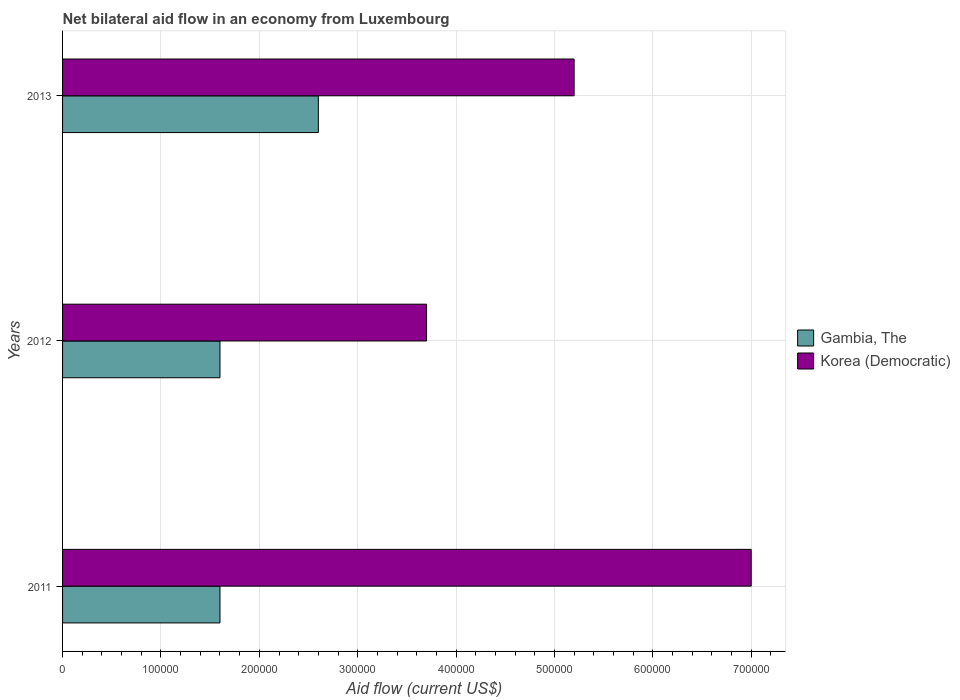How many bars are there on the 1st tick from the bottom?
Offer a terse response. 2. What is the label of the 1st group of bars from the top?
Offer a terse response. 2013. What is the net bilateral aid flow in Gambia, The in 2013?
Offer a very short reply. 2.60e+05. In which year was the net bilateral aid flow in Korea (Democratic) maximum?
Your response must be concise. 2011. In which year was the net bilateral aid flow in Gambia, The minimum?
Offer a very short reply. 2011. What is the total net bilateral aid flow in Gambia, The in the graph?
Your answer should be compact. 5.80e+05. What is the difference between the net bilateral aid flow in Gambia, The in 2011 and the net bilateral aid flow in Korea (Democratic) in 2013?
Offer a terse response. -3.60e+05. What is the average net bilateral aid flow in Gambia, The per year?
Provide a short and direct response. 1.93e+05. In the year 2011, what is the difference between the net bilateral aid flow in Gambia, The and net bilateral aid flow in Korea (Democratic)?
Your answer should be very brief. -5.40e+05. What is the ratio of the net bilateral aid flow in Korea (Democratic) in 2011 to that in 2013?
Ensure brevity in your answer.  1.35. Is the difference between the net bilateral aid flow in Gambia, The in 2011 and 2012 greater than the difference between the net bilateral aid flow in Korea (Democratic) in 2011 and 2012?
Offer a terse response. No. Is the sum of the net bilateral aid flow in Gambia, The in 2012 and 2013 greater than the maximum net bilateral aid flow in Korea (Democratic) across all years?
Make the answer very short. No. What does the 1st bar from the top in 2013 represents?
Provide a short and direct response. Korea (Democratic). What does the 1st bar from the bottom in 2013 represents?
Keep it short and to the point. Gambia, The. Are the values on the major ticks of X-axis written in scientific E-notation?
Make the answer very short. No. Where does the legend appear in the graph?
Provide a succinct answer. Center right. What is the title of the graph?
Give a very brief answer. Net bilateral aid flow in an economy from Luxembourg. What is the label or title of the Y-axis?
Keep it short and to the point. Years. What is the Aid flow (current US$) of Gambia, The in 2012?
Provide a short and direct response. 1.60e+05. What is the Aid flow (current US$) of Gambia, The in 2013?
Give a very brief answer. 2.60e+05. What is the Aid flow (current US$) of Korea (Democratic) in 2013?
Your answer should be very brief. 5.20e+05. Across all years, what is the maximum Aid flow (current US$) of Korea (Democratic)?
Provide a succinct answer. 7.00e+05. Across all years, what is the minimum Aid flow (current US$) in Gambia, The?
Your answer should be compact. 1.60e+05. What is the total Aid flow (current US$) of Gambia, The in the graph?
Keep it short and to the point. 5.80e+05. What is the total Aid flow (current US$) of Korea (Democratic) in the graph?
Provide a short and direct response. 1.59e+06. What is the difference between the Aid flow (current US$) of Korea (Democratic) in 2012 and that in 2013?
Provide a succinct answer. -1.50e+05. What is the difference between the Aid flow (current US$) in Gambia, The in 2011 and the Aid flow (current US$) in Korea (Democratic) in 2012?
Keep it short and to the point. -2.10e+05. What is the difference between the Aid flow (current US$) in Gambia, The in 2011 and the Aid flow (current US$) in Korea (Democratic) in 2013?
Offer a very short reply. -3.60e+05. What is the difference between the Aid flow (current US$) in Gambia, The in 2012 and the Aid flow (current US$) in Korea (Democratic) in 2013?
Keep it short and to the point. -3.60e+05. What is the average Aid flow (current US$) in Gambia, The per year?
Provide a succinct answer. 1.93e+05. What is the average Aid flow (current US$) of Korea (Democratic) per year?
Offer a terse response. 5.30e+05. In the year 2011, what is the difference between the Aid flow (current US$) in Gambia, The and Aid flow (current US$) in Korea (Democratic)?
Provide a succinct answer. -5.40e+05. In the year 2012, what is the difference between the Aid flow (current US$) of Gambia, The and Aid flow (current US$) of Korea (Democratic)?
Provide a short and direct response. -2.10e+05. In the year 2013, what is the difference between the Aid flow (current US$) in Gambia, The and Aid flow (current US$) in Korea (Democratic)?
Your answer should be very brief. -2.60e+05. What is the ratio of the Aid flow (current US$) in Gambia, The in 2011 to that in 2012?
Give a very brief answer. 1. What is the ratio of the Aid flow (current US$) of Korea (Democratic) in 2011 to that in 2012?
Provide a short and direct response. 1.89. What is the ratio of the Aid flow (current US$) of Gambia, The in 2011 to that in 2013?
Your answer should be compact. 0.62. What is the ratio of the Aid flow (current US$) of Korea (Democratic) in 2011 to that in 2013?
Offer a very short reply. 1.35. What is the ratio of the Aid flow (current US$) in Gambia, The in 2012 to that in 2013?
Your response must be concise. 0.62. What is the ratio of the Aid flow (current US$) in Korea (Democratic) in 2012 to that in 2013?
Keep it short and to the point. 0.71. What is the difference between the highest and the second highest Aid flow (current US$) in Gambia, The?
Ensure brevity in your answer.  1.00e+05. What is the difference between the highest and the second highest Aid flow (current US$) of Korea (Democratic)?
Your answer should be very brief. 1.80e+05. What is the difference between the highest and the lowest Aid flow (current US$) in Gambia, The?
Your answer should be very brief. 1.00e+05. 